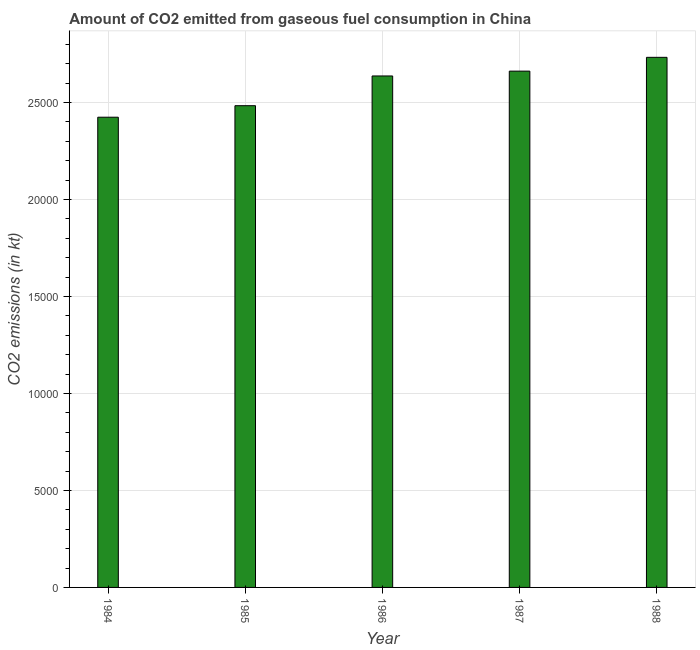Does the graph contain any zero values?
Your answer should be compact. No. What is the title of the graph?
Your response must be concise. Amount of CO2 emitted from gaseous fuel consumption in China. What is the label or title of the Y-axis?
Keep it short and to the point. CO2 emissions (in kt). What is the co2 emissions from gaseous fuel consumption in 1987?
Keep it short and to the point. 2.66e+04. Across all years, what is the maximum co2 emissions from gaseous fuel consumption?
Keep it short and to the point. 2.73e+04. Across all years, what is the minimum co2 emissions from gaseous fuel consumption?
Give a very brief answer. 2.42e+04. In which year was the co2 emissions from gaseous fuel consumption maximum?
Give a very brief answer. 1988. What is the sum of the co2 emissions from gaseous fuel consumption?
Offer a terse response. 1.29e+05. What is the difference between the co2 emissions from gaseous fuel consumption in 1986 and 1988?
Your response must be concise. -960.75. What is the average co2 emissions from gaseous fuel consumption per year?
Your answer should be compact. 2.59e+04. What is the median co2 emissions from gaseous fuel consumption?
Your answer should be very brief. 2.64e+04. Do a majority of the years between 1987 and 1984 (inclusive) have co2 emissions from gaseous fuel consumption greater than 12000 kt?
Your answer should be very brief. Yes. What is the ratio of the co2 emissions from gaseous fuel consumption in 1984 to that in 1988?
Give a very brief answer. 0.89. Is the co2 emissions from gaseous fuel consumption in 1985 less than that in 1988?
Provide a succinct answer. Yes. What is the difference between the highest and the second highest co2 emissions from gaseous fuel consumption?
Provide a succinct answer. 711.4. What is the difference between the highest and the lowest co2 emissions from gaseous fuel consumption?
Provide a succinct answer. 3087.61. How many bars are there?
Offer a terse response. 5. Are all the bars in the graph horizontal?
Give a very brief answer. No. How many years are there in the graph?
Your response must be concise. 5. What is the difference between two consecutive major ticks on the Y-axis?
Make the answer very short. 5000. Are the values on the major ticks of Y-axis written in scientific E-notation?
Keep it short and to the point. No. What is the CO2 emissions (in kt) in 1984?
Provide a succinct answer. 2.42e+04. What is the CO2 emissions (in kt) of 1985?
Your response must be concise. 2.48e+04. What is the CO2 emissions (in kt) in 1986?
Make the answer very short. 2.64e+04. What is the CO2 emissions (in kt) in 1987?
Keep it short and to the point. 2.66e+04. What is the CO2 emissions (in kt) in 1988?
Give a very brief answer. 2.73e+04. What is the difference between the CO2 emissions (in kt) in 1984 and 1985?
Keep it short and to the point. -594.05. What is the difference between the CO2 emissions (in kt) in 1984 and 1986?
Your response must be concise. -2126.86. What is the difference between the CO2 emissions (in kt) in 1984 and 1987?
Your answer should be very brief. -2376.22. What is the difference between the CO2 emissions (in kt) in 1984 and 1988?
Your response must be concise. -3087.61. What is the difference between the CO2 emissions (in kt) in 1985 and 1986?
Provide a short and direct response. -1532.81. What is the difference between the CO2 emissions (in kt) in 1985 and 1987?
Give a very brief answer. -1782.16. What is the difference between the CO2 emissions (in kt) in 1985 and 1988?
Offer a very short reply. -2493.56. What is the difference between the CO2 emissions (in kt) in 1986 and 1987?
Provide a short and direct response. -249.36. What is the difference between the CO2 emissions (in kt) in 1986 and 1988?
Ensure brevity in your answer.  -960.75. What is the difference between the CO2 emissions (in kt) in 1987 and 1988?
Provide a succinct answer. -711.4. What is the ratio of the CO2 emissions (in kt) in 1984 to that in 1985?
Offer a very short reply. 0.98. What is the ratio of the CO2 emissions (in kt) in 1984 to that in 1986?
Your answer should be compact. 0.92. What is the ratio of the CO2 emissions (in kt) in 1984 to that in 1987?
Provide a succinct answer. 0.91. What is the ratio of the CO2 emissions (in kt) in 1984 to that in 1988?
Your response must be concise. 0.89. What is the ratio of the CO2 emissions (in kt) in 1985 to that in 1986?
Ensure brevity in your answer.  0.94. What is the ratio of the CO2 emissions (in kt) in 1985 to that in 1987?
Give a very brief answer. 0.93. What is the ratio of the CO2 emissions (in kt) in 1985 to that in 1988?
Provide a succinct answer. 0.91. What is the ratio of the CO2 emissions (in kt) in 1987 to that in 1988?
Offer a terse response. 0.97. 